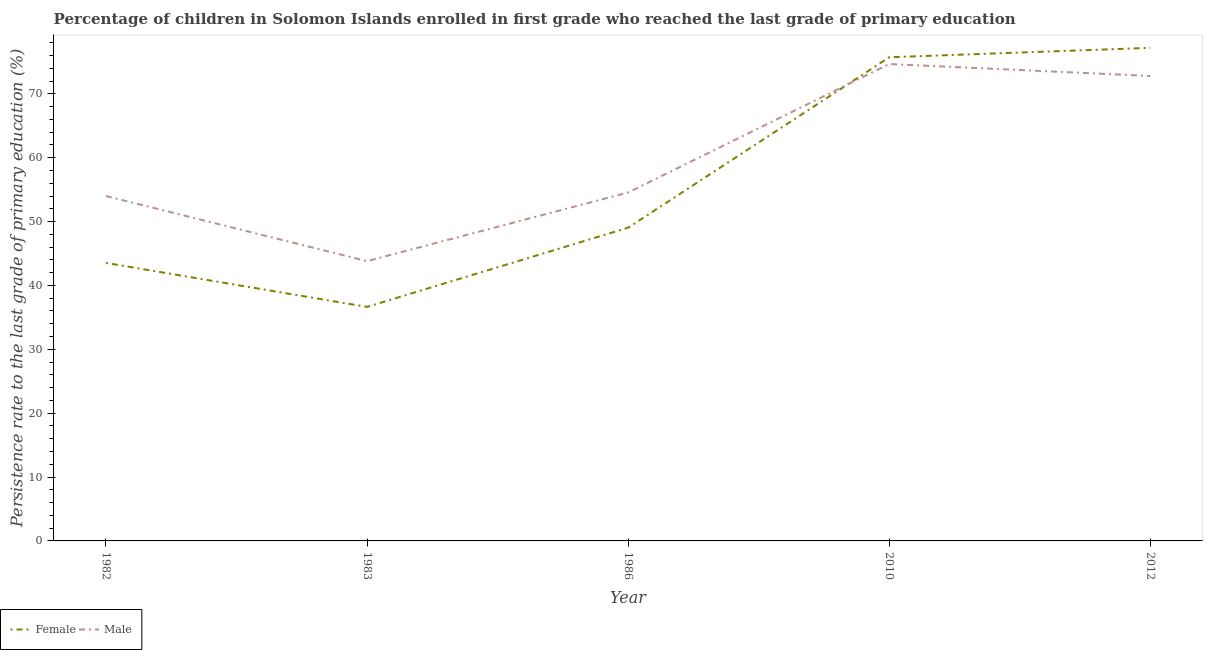Is the number of lines equal to the number of legend labels?
Make the answer very short. Yes. What is the persistence rate of female students in 2012?
Make the answer very short. 77.2. Across all years, what is the maximum persistence rate of male students?
Your answer should be very brief. 74.67. Across all years, what is the minimum persistence rate of male students?
Your response must be concise. 43.81. In which year was the persistence rate of female students maximum?
Make the answer very short. 2012. In which year was the persistence rate of female students minimum?
Give a very brief answer. 1983. What is the total persistence rate of female students in the graph?
Your answer should be compact. 282.14. What is the difference between the persistence rate of female students in 1983 and that in 2010?
Offer a very short reply. -39.08. What is the difference between the persistence rate of male students in 1986 and the persistence rate of female students in 2010?
Offer a terse response. -21.17. What is the average persistence rate of male students per year?
Offer a terse response. 59.96. In the year 1986, what is the difference between the persistence rate of male students and persistence rate of female students?
Keep it short and to the point. 5.52. What is the ratio of the persistence rate of male students in 1982 to that in 2010?
Your response must be concise. 0.72. What is the difference between the highest and the second highest persistence rate of male students?
Keep it short and to the point. 1.87. What is the difference between the highest and the lowest persistence rate of female students?
Make the answer very short. 40.56. Is the sum of the persistence rate of female students in 1983 and 2010 greater than the maximum persistence rate of male students across all years?
Offer a terse response. Yes. Is the persistence rate of male students strictly greater than the persistence rate of female students over the years?
Ensure brevity in your answer.  No. How many years are there in the graph?
Give a very brief answer. 5. What is the difference between two consecutive major ticks on the Y-axis?
Give a very brief answer. 10. Does the graph contain grids?
Keep it short and to the point. No. What is the title of the graph?
Keep it short and to the point. Percentage of children in Solomon Islands enrolled in first grade who reached the last grade of primary education. What is the label or title of the Y-axis?
Your answer should be compact. Persistence rate to the last grade of primary education (%). What is the Persistence rate to the last grade of primary education (%) in Female in 1982?
Your answer should be very brief. 43.53. What is the Persistence rate to the last grade of primary education (%) of Male in 1982?
Keep it short and to the point. 54. What is the Persistence rate to the last grade of primary education (%) of Female in 1983?
Your answer should be very brief. 36.64. What is the Persistence rate to the last grade of primary education (%) in Male in 1983?
Offer a terse response. 43.81. What is the Persistence rate to the last grade of primary education (%) of Female in 1986?
Your answer should be very brief. 49.04. What is the Persistence rate to the last grade of primary education (%) of Male in 1986?
Provide a succinct answer. 54.55. What is the Persistence rate to the last grade of primary education (%) of Female in 2010?
Your answer should be very brief. 75.73. What is the Persistence rate to the last grade of primary education (%) of Male in 2010?
Your answer should be compact. 74.67. What is the Persistence rate to the last grade of primary education (%) of Female in 2012?
Your answer should be compact. 77.2. What is the Persistence rate to the last grade of primary education (%) of Male in 2012?
Provide a short and direct response. 72.79. Across all years, what is the maximum Persistence rate to the last grade of primary education (%) in Female?
Provide a succinct answer. 77.2. Across all years, what is the maximum Persistence rate to the last grade of primary education (%) in Male?
Keep it short and to the point. 74.67. Across all years, what is the minimum Persistence rate to the last grade of primary education (%) of Female?
Your answer should be very brief. 36.64. Across all years, what is the minimum Persistence rate to the last grade of primary education (%) of Male?
Provide a succinct answer. 43.81. What is the total Persistence rate to the last grade of primary education (%) in Female in the graph?
Make the answer very short. 282.14. What is the total Persistence rate to the last grade of primary education (%) in Male in the graph?
Make the answer very short. 299.82. What is the difference between the Persistence rate to the last grade of primary education (%) in Female in 1982 and that in 1983?
Your answer should be compact. 6.88. What is the difference between the Persistence rate to the last grade of primary education (%) of Male in 1982 and that in 1983?
Ensure brevity in your answer.  10.19. What is the difference between the Persistence rate to the last grade of primary education (%) of Female in 1982 and that in 1986?
Provide a succinct answer. -5.51. What is the difference between the Persistence rate to the last grade of primary education (%) of Male in 1982 and that in 1986?
Offer a terse response. -0.55. What is the difference between the Persistence rate to the last grade of primary education (%) in Female in 1982 and that in 2010?
Offer a terse response. -32.2. What is the difference between the Persistence rate to the last grade of primary education (%) of Male in 1982 and that in 2010?
Provide a short and direct response. -20.66. What is the difference between the Persistence rate to the last grade of primary education (%) in Female in 1982 and that in 2012?
Your response must be concise. -33.68. What is the difference between the Persistence rate to the last grade of primary education (%) of Male in 1982 and that in 2012?
Provide a succinct answer. -18.79. What is the difference between the Persistence rate to the last grade of primary education (%) of Female in 1983 and that in 1986?
Give a very brief answer. -12.4. What is the difference between the Persistence rate to the last grade of primary education (%) of Male in 1983 and that in 1986?
Provide a short and direct response. -10.75. What is the difference between the Persistence rate to the last grade of primary education (%) in Female in 1983 and that in 2010?
Keep it short and to the point. -39.08. What is the difference between the Persistence rate to the last grade of primary education (%) in Male in 1983 and that in 2010?
Your answer should be very brief. -30.86. What is the difference between the Persistence rate to the last grade of primary education (%) of Female in 1983 and that in 2012?
Your response must be concise. -40.56. What is the difference between the Persistence rate to the last grade of primary education (%) in Male in 1983 and that in 2012?
Keep it short and to the point. -28.99. What is the difference between the Persistence rate to the last grade of primary education (%) in Female in 1986 and that in 2010?
Your response must be concise. -26.69. What is the difference between the Persistence rate to the last grade of primary education (%) in Male in 1986 and that in 2010?
Your answer should be very brief. -20.11. What is the difference between the Persistence rate to the last grade of primary education (%) of Female in 1986 and that in 2012?
Make the answer very short. -28.16. What is the difference between the Persistence rate to the last grade of primary education (%) in Male in 1986 and that in 2012?
Keep it short and to the point. -18.24. What is the difference between the Persistence rate to the last grade of primary education (%) in Female in 2010 and that in 2012?
Give a very brief answer. -1.48. What is the difference between the Persistence rate to the last grade of primary education (%) in Male in 2010 and that in 2012?
Provide a short and direct response. 1.87. What is the difference between the Persistence rate to the last grade of primary education (%) of Female in 1982 and the Persistence rate to the last grade of primary education (%) of Male in 1983?
Provide a short and direct response. -0.28. What is the difference between the Persistence rate to the last grade of primary education (%) in Female in 1982 and the Persistence rate to the last grade of primary education (%) in Male in 1986?
Provide a short and direct response. -11.03. What is the difference between the Persistence rate to the last grade of primary education (%) of Female in 1982 and the Persistence rate to the last grade of primary education (%) of Male in 2010?
Provide a succinct answer. -31.14. What is the difference between the Persistence rate to the last grade of primary education (%) of Female in 1982 and the Persistence rate to the last grade of primary education (%) of Male in 2012?
Your answer should be compact. -29.27. What is the difference between the Persistence rate to the last grade of primary education (%) of Female in 1983 and the Persistence rate to the last grade of primary education (%) of Male in 1986?
Make the answer very short. -17.91. What is the difference between the Persistence rate to the last grade of primary education (%) of Female in 1983 and the Persistence rate to the last grade of primary education (%) of Male in 2010?
Keep it short and to the point. -38.02. What is the difference between the Persistence rate to the last grade of primary education (%) of Female in 1983 and the Persistence rate to the last grade of primary education (%) of Male in 2012?
Provide a short and direct response. -36.15. What is the difference between the Persistence rate to the last grade of primary education (%) of Female in 1986 and the Persistence rate to the last grade of primary education (%) of Male in 2010?
Your answer should be very brief. -25.63. What is the difference between the Persistence rate to the last grade of primary education (%) of Female in 1986 and the Persistence rate to the last grade of primary education (%) of Male in 2012?
Give a very brief answer. -23.76. What is the difference between the Persistence rate to the last grade of primary education (%) of Female in 2010 and the Persistence rate to the last grade of primary education (%) of Male in 2012?
Offer a very short reply. 2.93. What is the average Persistence rate to the last grade of primary education (%) of Female per year?
Keep it short and to the point. 56.43. What is the average Persistence rate to the last grade of primary education (%) of Male per year?
Provide a succinct answer. 59.96. In the year 1982, what is the difference between the Persistence rate to the last grade of primary education (%) in Female and Persistence rate to the last grade of primary education (%) in Male?
Your answer should be compact. -10.47. In the year 1983, what is the difference between the Persistence rate to the last grade of primary education (%) of Female and Persistence rate to the last grade of primary education (%) of Male?
Make the answer very short. -7.16. In the year 1986, what is the difference between the Persistence rate to the last grade of primary education (%) of Female and Persistence rate to the last grade of primary education (%) of Male?
Your answer should be very brief. -5.52. In the year 2010, what is the difference between the Persistence rate to the last grade of primary education (%) of Female and Persistence rate to the last grade of primary education (%) of Male?
Your answer should be compact. 1.06. In the year 2012, what is the difference between the Persistence rate to the last grade of primary education (%) of Female and Persistence rate to the last grade of primary education (%) of Male?
Provide a short and direct response. 4.41. What is the ratio of the Persistence rate to the last grade of primary education (%) of Female in 1982 to that in 1983?
Make the answer very short. 1.19. What is the ratio of the Persistence rate to the last grade of primary education (%) of Male in 1982 to that in 1983?
Offer a very short reply. 1.23. What is the ratio of the Persistence rate to the last grade of primary education (%) of Female in 1982 to that in 1986?
Your response must be concise. 0.89. What is the ratio of the Persistence rate to the last grade of primary education (%) of Male in 1982 to that in 1986?
Keep it short and to the point. 0.99. What is the ratio of the Persistence rate to the last grade of primary education (%) in Female in 1982 to that in 2010?
Offer a terse response. 0.57. What is the ratio of the Persistence rate to the last grade of primary education (%) of Male in 1982 to that in 2010?
Keep it short and to the point. 0.72. What is the ratio of the Persistence rate to the last grade of primary education (%) of Female in 1982 to that in 2012?
Offer a very short reply. 0.56. What is the ratio of the Persistence rate to the last grade of primary education (%) in Male in 1982 to that in 2012?
Keep it short and to the point. 0.74. What is the ratio of the Persistence rate to the last grade of primary education (%) of Female in 1983 to that in 1986?
Offer a very short reply. 0.75. What is the ratio of the Persistence rate to the last grade of primary education (%) of Male in 1983 to that in 1986?
Give a very brief answer. 0.8. What is the ratio of the Persistence rate to the last grade of primary education (%) in Female in 1983 to that in 2010?
Your response must be concise. 0.48. What is the ratio of the Persistence rate to the last grade of primary education (%) in Male in 1983 to that in 2010?
Ensure brevity in your answer.  0.59. What is the ratio of the Persistence rate to the last grade of primary education (%) in Female in 1983 to that in 2012?
Make the answer very short. 0.47. What is the ratio of the Persistence rate to the last grade of primary education (%) in Male in 1983 to that in 2012?
Your answer should be very brief. 0.6. What is the ratio of the Persistence rate to the last grade of primary education (%) of Female in 1986 to that in 2010?
Your answer should be very brief. 0.65. What is the ratio of the Persistence rate to the last grade of primary education (%) of Male in 1986 to that in 2010?
Your answer should be very brief. 0.73. What is the ratio of the Persistence rate to the last grade of primary education (%) in Female in 1986 to that in 2012?
Your answer should be very brief. 0.64. What is the ratio of the Persistence rate to the last grade of primary education (%) of Male in 1986 to that in 2012?
Ensure brevity in your answer.  0.75. What is the ratio of the Persistence rate to the last grade of primary education (%) of Female in 2010 to that in 2012?
Provide a short and direct response. 0.98. What is the ratio of the Persistence rate to the last grade of primary education (%) of Male in 2010 to that in 2012?
Your response must be concise. 1.03. What is the difference between the highest and the second highest Persistence rate to the last grade of primary education (%) in Female?
Your answer should be very brief. 1.48. What is the difference between the highest and the second highest Persistence rate to the last grade of primary education (%) in Male?
Provide a short and direct response. 1.87. What is the difference between the highest and the lowest Persistence rate to the last grade of primary education (%) of Female?
Provide a short and direct response. 40.56. What is the difference between the highest and the lowest Persistence rate to the last grade of primary education (%) in Male?
Give a very brief answer. 30.86. 